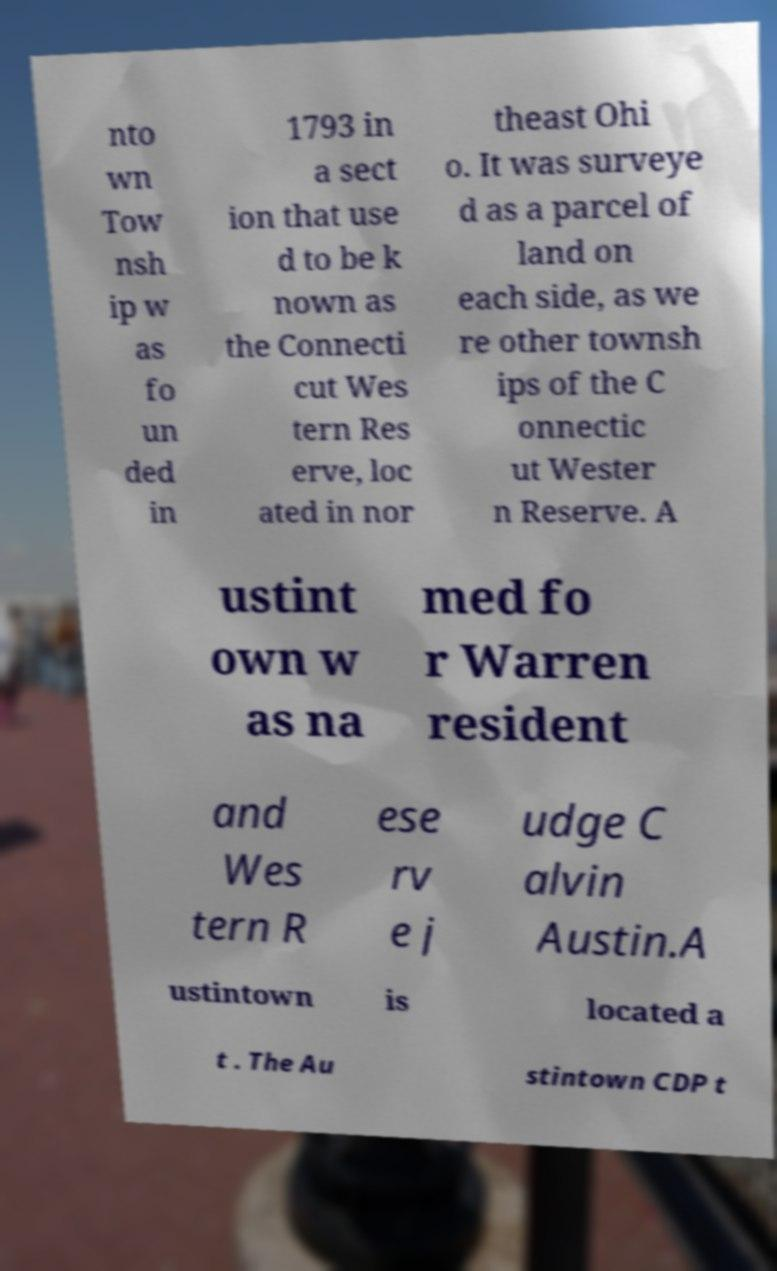Please identify and transcribe the text found in this image. nto wn Tow nsh ip w as fo un ded in 1793 in a sect ion that use d to be k nown as the Connecti cut Wes tern Res erve, loc ated in nor theast Ohi o. It was surveye d as a parcel of land on each side, as we re other townsh ips of the C onnectic ut Wester n Reserve. A ustint own w as na med fo r Warren resident and Wes tern R ese rv e j udge C alvin Austin.A ustintown is located a t . The Au stintown CDP t 